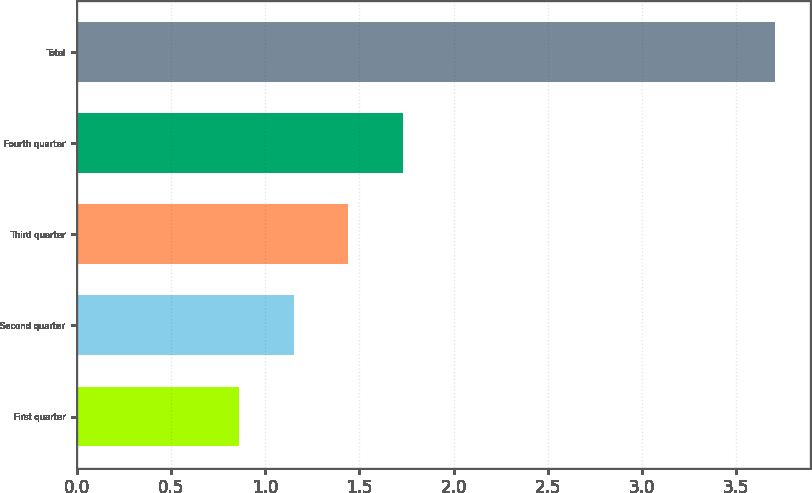Convert chart to OTSL. <chart><loc_0><loc_0><loc_500><loc_500><bar_chart><fcel>First quarter<fcel>Second quarter<fcel>Third quarter<fcel>Fourth quarter<fcel>Total<nl><fcel>0.86<fcel>1.15<fcel>1.44<fcel>1.73<fcel>3.71<nl></chart> 